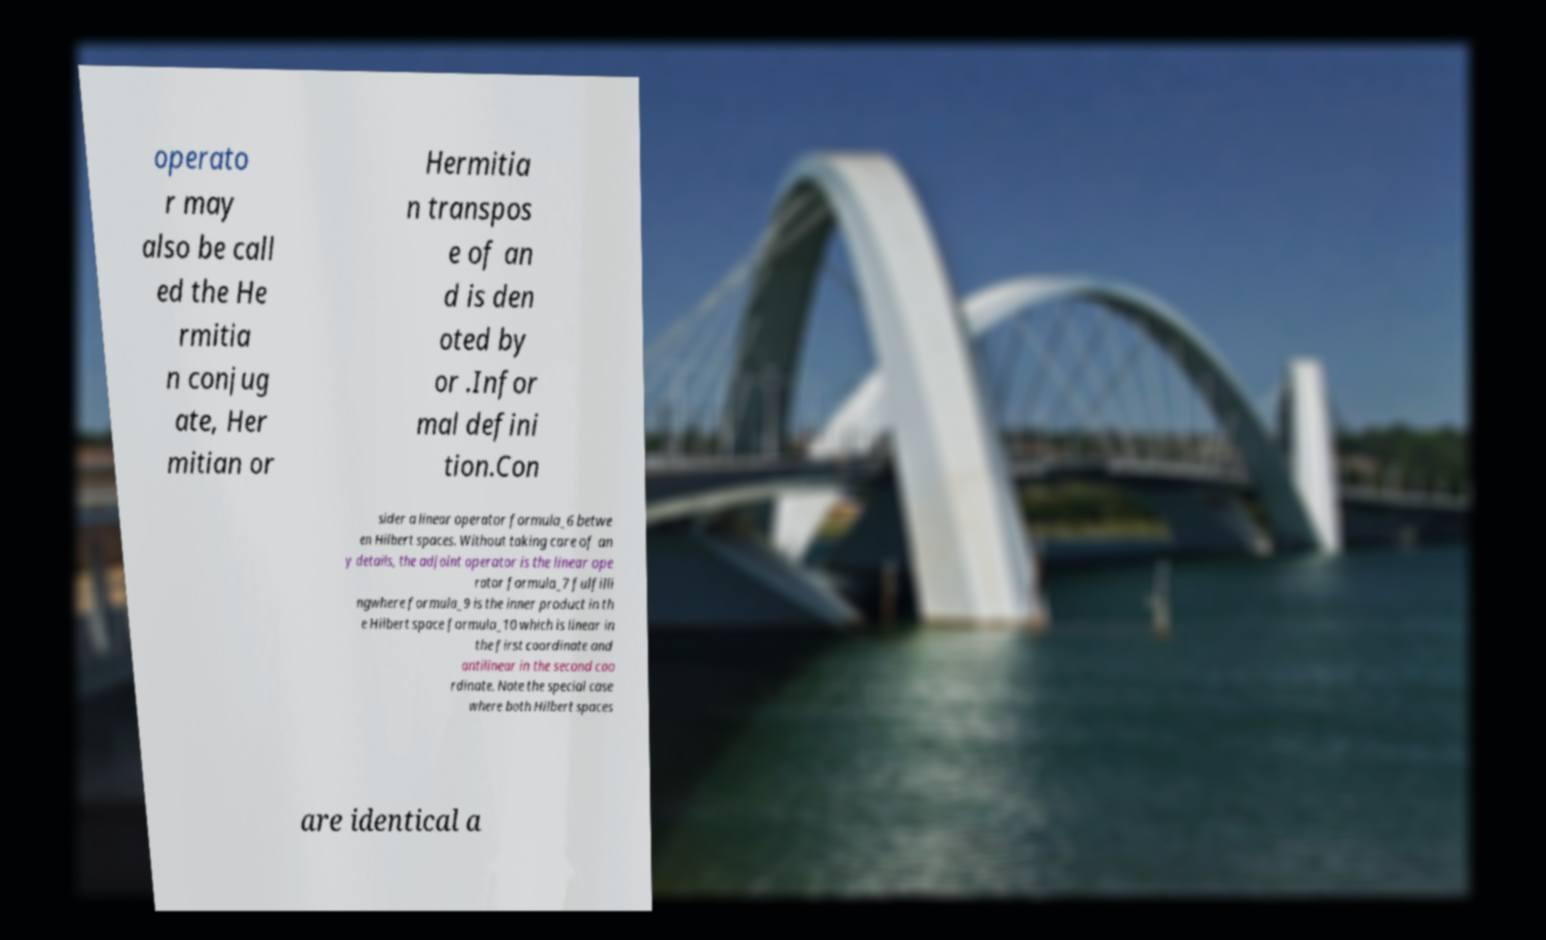Please read and relay the text visible in this image. What does it say? operato r may also be call ed the He rmitia n conjug ate, Her mitian or Hermitia n transpos e of an d is den oted by or .Infor mal defini tion.Con sider a linear operator formula_6 betwe en Hilbert spaces. Without taking care of an y details, the adjoint operator is the linear ope rator formula_7 fulfilli ngwhere formula_9 is the inner product in th e Hilbert space formula_10 which is linear in the first coordinate and antilinear in the second coo rdinate. Note the special case where both Hilbert spaces are identical a 